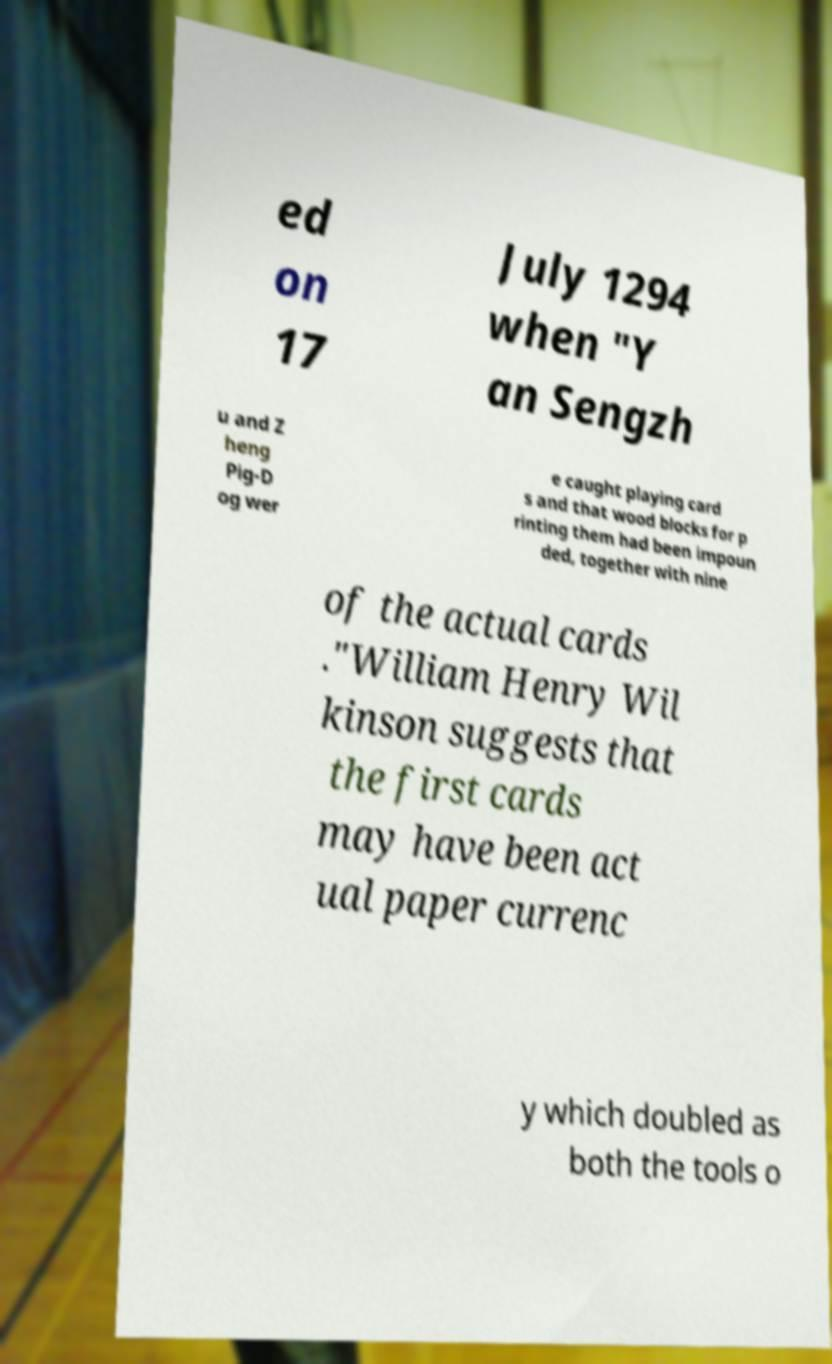Please identify and transcribe the text found in this image. ed on 17 July 1294 when "Y an Sengzh u and Z heng Pig-D og wer e caught playing card s and that wood blocks for p rinting them had been impoun ded, together with nine of the actual cards ."William Henry Wil kinson suggests that the first cards may have been act ual paper currenc y which doubled as both the tools o 